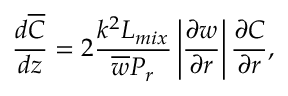<formula> <loc_0><loc_0><loc_500><loc_500>\frac { d \overline { C } } { d z } = 2 \frac { k ^ { 2 } { L _ { m i x } } } { \overline { w } P _ { r } } \left | \frac { \partial w } { \partial r } \right | \frac { \partial C } { \partial r } ,</formula> 